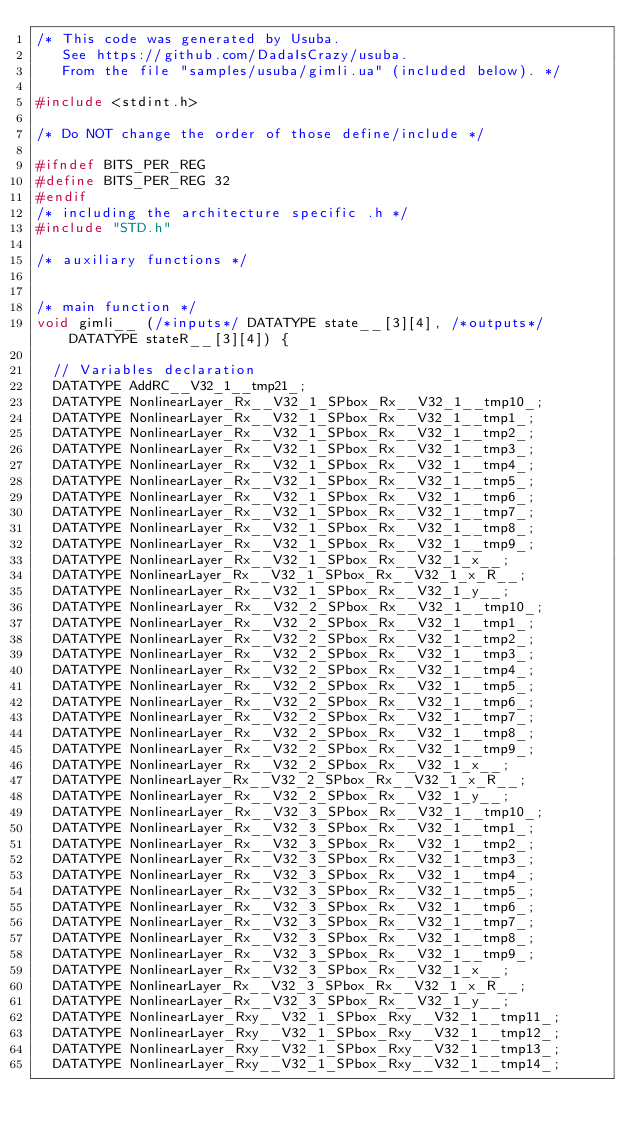Convert code to text. <code><loc_0><loc_0><loc_500><loc_500><_C_>/* This code was generated by Usuba.
   See https://github.com/DadaIsCrazy/usuba.
   From the file "samples/usuba/gimli.ua" (included below). */

#include <stdint.h>

/* Do NOT change the order of those define/include */

#ifndef BITS_PER_REG
#define BITS_PER_REG 32
#endif
/* including the architecture specific .h */
#include "STD.h"

/* auxiliary functions */


/* main function */
void gimli__ (/*inputs*/ DATATYPE state__[3][4], /*outputs*/ DATATYPE stateR__[3][4]) {

  // Variables declaration
  DATATYPE AddRC__V32_1__tmp21_;
  DATATYPE NonlinearLayer_Rx__V32_1_SPbox_Rx__V32_1__tmp10_;
  DATATYPE NonlinearLayer_Rx__V32_1_SPbox_Rx__V32_1__tmp1_;
  DATATYPE NonlinearLayer_Rx__V32_1_SPbox_Rx__V32_1__tmp2_;
  DATATYPE NonlinearLayer_Rx__V32_1_SPbox_Rx__V32_1__tmp3_;
  DATATYPE NonlinearLayer_Rx__V32_1_SPbox_Rx__V32_1__tmp4_;
  DATATYPE NonlinearLayer_Rx__V32_1_SPbox_Rx__V32_1__tmp5_;
  DATATYPE NonlinearLayer_Rx__V32_1_SPbox_Rx__V32_1__tmp6_;
  DATATYPE NonlinearLayer_Rx__V32_1_SPbox_Rx__V32_1__tmp7_;
  DATATYPE NonlinearLayer_Rx__V32_1_SPbox_Rx__V32_1__tmp8_;
  DATATYPE NonlinearLayer_Rx__V32_1_SPbox_Rx__V32_1__tmp9_;
  DATATYPE NonlinearLayer_Rx__V32_1_SPbox_Rx__V32_1_x__;
  DATATYPE NonlinearLayer_Rx__V32_1_SPbox_Rx__V32_1_x_R__;
  DATATYPE NonlinearLayer_Rx__V32_1_SPbox_Rx__V32_1_y__;
  DATATYPE NonlinearLayer_Rx__V32_2_SPbox_Rx__V32_1__tmp10_;
  DATATYPE NonlinearLayer_Rx__V32_2_SPbox_Rx__V32_1__tmp1_;
  DATATYPE NonlinearLayer_Rx__V32_2_SPbox_Rx__V32_1__tmp2_;
  DATATYPE NonlinearLayer_Rx__V32_2_SPbox_Rx__V32_1__tmp3_;
  DATATYPE NonlinearLayer_Rx__V32_2_SPbox_Rx__V32_1__tmp4_;
  DATATYPE NonlinearLayer_Rx__V32_2_SPbox_Rx__V32_1__tmp5_;
  DATATYPE NonlinearLayer_Rx__V32_2_SPbox_Rx__V32_1__tmp6_;
  DATATYPE NonlinearLayer_Rx__V32_2_SPbox_Rx__V32_1__tmp7_;
  DATATYPE NonlinearLayer_Rx__V32_2_SPbox_Rx__V32_1__tmp8_;
  DATATYPE NonlinearLayer_Rx__V32_2_SPbox_Rx__V32_1__tmp9_;
  DATATYPE NonlinearLayer_Rx__V32_2_SPbox_Rx__V32_1_x__;
  DATATYPE NonlinearLayer_Rx__V32_2_SPbox_Rx__V32_1_x_R__;
  DATATYPE NonlinearLayer_Rx__V32_2_SPbox_Rx__V32_1_y__;
  DATATYPE NonlinearLayer_Rx__V32_3_SPbox_Rx__V32_1__tmp10_;
  DATATYPE NonlinearLayer_Rx__V32_3_SPbox_Rx__V32_1__tmp1_;
  DATATYPE NonlinearLayer_Rx__V32_3_SPbox_Rx__V32_1__tmp2_;
  DATATYPE NonlinearLayer_Rx__V32_3_SPbox_Rx__V32_1__tmp3_;
  DATATYPE NonlinearLayer_Rx__V32_3_SPbox_Rx__V32_1__tmp4_;
  DATATYPE NonlinearLayer_Rx__V32_3_SPbox_Rx__V32_1__tmp5_;
  DATATYPE NonlinearLayer_Rx__V32_3_SPbox_Rx__V32_1__tmp6_;
  DATATYPE NonlinearLayer_Rx__V32_3_SPbox_Rx__V32_1__tmp7_;
  DATATYPE NonlinearLayer_Rx__V32_3_SPbox_Rx__V32_1__tmp8_;
  DATATYPE NonlinearLayer_Rx__V32_3_SPbox_Rx__V32_1__tmp9_;
  DATATYPE NonlinearLayer_Rx__V32_3_SPbox_Rx__V32_1_x__;
  DATATYPE NonlinearLayer_Rx__V32_3_SPbox_Rx__V32_1_x_R__;
  DATATYPE NonlinearLayer_Rx__V32_3_SPbox_Rx__V32_1_y__;
  DATATYPE NonlinearLayer_Rxy__V32_1_SPbox_Rxy__V32_1__tmp11_;
  DATATYPE NonlinearLayer_Rxy__V32_1_SPbox_Rxy__V32_1__tmp12_;
  DATATYPE NonlinearLayer_Rxy__V32_1_SPbox_Rxy__V32_1__tmp13_;
  DATATYPE NonlinearLayer_Rxy__V32_1_SPbox_Rxy__V32_1__tmp14_;</code> 